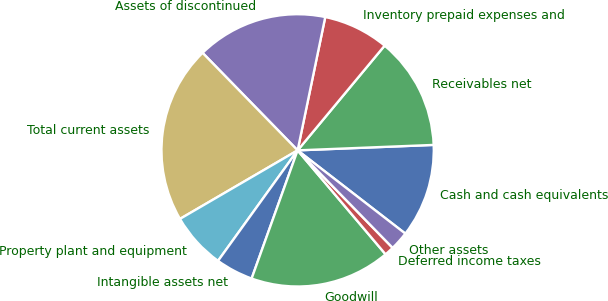Convert chart to OTSL. <chart><loc_0><loc_0><loc_500><loc_500><pie_chart><fcel>Cash and cash equivalents<fcel>Receivables net<fcel>Inventory prepaid expenses and<fcel>Assets of discontinued<fcel>Total current assets<fcel>Property plant and equipment<fcel>Intangible assets net<fcel>Goodwill<fcel>Deferred income taxes<fcel>Other assets<nl><fcel>11.11%<fcel>13.33%<fcel>7.78%<fcel>15.55%<fcel>21.1%<fcel>6.67%<fcel>4.45%<fcel>16.66%<fcel>1.12%<fcel>2.23%<nl></chart> 